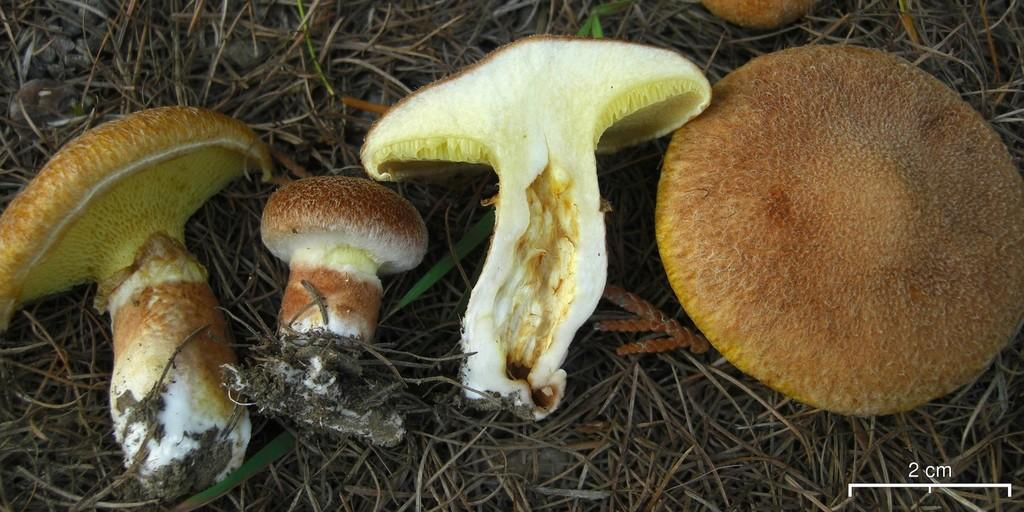What type of fungi can be seen in the image? There are mushrooms in the image. What colors are the mushrooms in the image? The mushrooms are in white and brown colors. Where are the mushrooms located in the image? The mushrooms are on the grass. Can you see any guns or worms in the image? No, there are no guns or worms present in the image; it features mushrooms on the grass. 